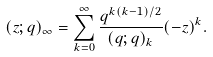<formula> <loc_0><loc_0><loc_500><loc_500>( z ; q ) _ { \infty } = \sum _ { k = 0 } ^ { \infty } \frac { q ^ { k ( k - 1 ) / 2 } } { ( q ; q ) _ { k } } ( - z ) ^ { k } .</formula> 